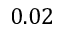Convert formula to latex. <formula><loc_0><loc_0><loc_500><loc_500>0 . 0 2</formula> 